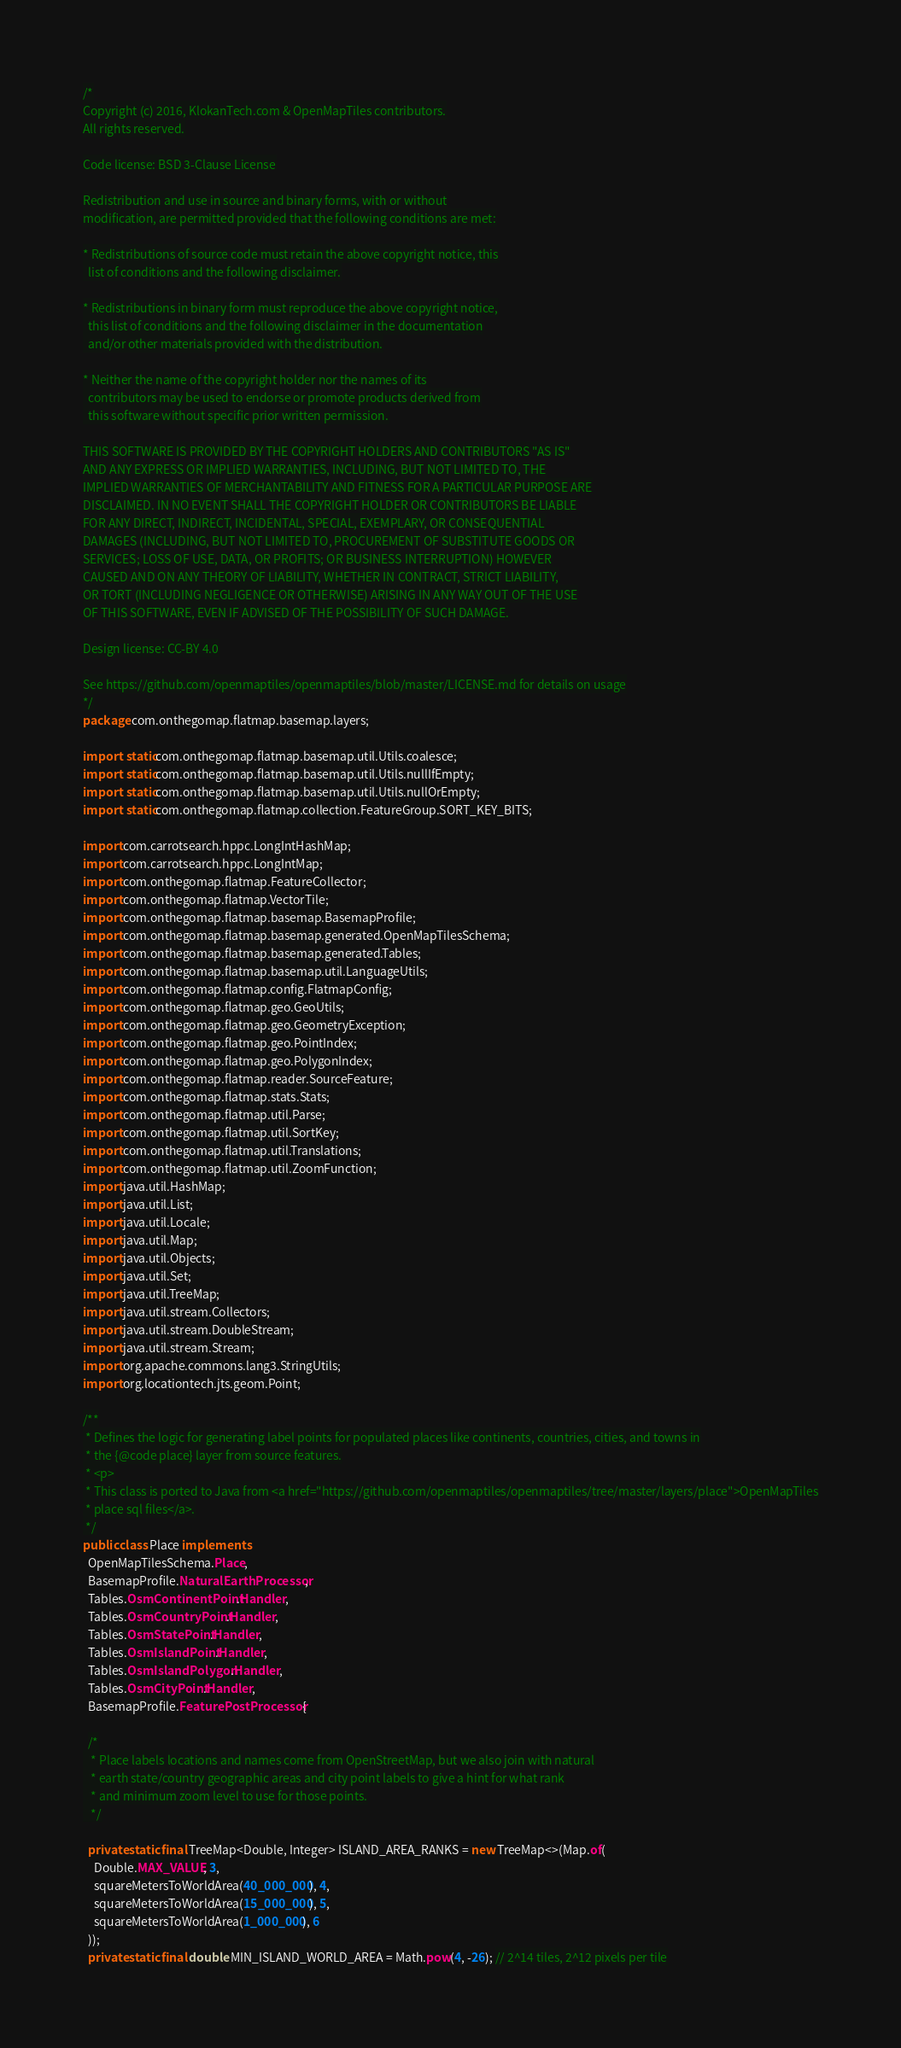Convert code to text. <code><loc_0><loc_0><loc_500><loc_500><_Java_>/*
Copyright (c) 2016, KlokanTech.com & OpenMapTiles contributors.
All rights reserved.

Code license: BSD 3-Clause License

Redistribution and use in source and binary forms, with or without
modification, are permitted provided that the following conditions are met:

* Redistributions of source code must retain the above copyright notice, this
  list of conditions and the following disclaimer.

* Redistributions in binary form must reproduce the above copyright notice,
  this list of conditions and the following disclaimer in the documentation
  and/or other materials provided with the distribution.

* Neither the name of the copyright holder nor the names of its
  contributors may be used to endorse or promote products derived from
  this software without specific prior written permission.

THIS SOFTWARE IS PROVIDED BY THE COPYRIGHT HOLDERS AND CONTRIBUTORS "AS IS"
AND ANY EXPRESS OR IMPLIED WARRANTIES, INCLUDING, BUT NOT LIMITED TO, THE
IMPLIED WARRANTIES OF MERCHANTABILITY AND FITNESS FOR A PARTICULAR PURPOSE ARE
DISCLAIMED. IN NO EVENT SHALL THE COPYRIGHT HOLDER OR CONTRIBUTORS BE LIABLE
FOR ANY DIRECT, INDIRECT, INCIDENTAL, SPECIAL, EXEMPLARY, OR CONSEQUENTIAL
DAMAGES (INCLUDING, BUT NOT LIMITED TO, PROCUREMENT OF SUBSTITUTE GOODS OR
SERVICES; LOSS OF USE, DATA, OR PROFITS; OR BUSINESS INTERRUPTION) HOWEVER
CAUSED AND ON ANY THEORY OF LIABILITY, WHETHER IN CONTRACT, STRICT LIABILITY,
OR TORT (INCLUDING NEGLIGENCE OR OTHERWISE) ARISING IN ANY WAY OUT OF THE USE
OF THIS SOFTWARE, EVEN IF ADVISED OF THE POSSIBILITY OF SUCH DAMAGE.

Design license: CC-BY 4.0

See https://github.com/openmaptiles/openmaptiles/blob/master/LICENSE.md for details on usage
*/
package com.onthegomap.flatmap.basemap.layers;

import static com.onthegomap.flatmap.basemap.util.Utils.coalesce;
import static com.onthegomap.flatmap.basemap.util.Utils.nullIfEmpty;
import static com.onthegomap.flatmap.basemap.util.Utils.nullOrEmpty;
import static com.onthegomap.flatmap.collection.FeatureGroup.SORT_KEY_BITS;

import com.carrotsearch.hppc.LongIntHashMap;
import com.carrotsearch.hppc.LongIntMap;
import com.onthegomap.flatmap.FeatureCollector;
import com.onthegomap.flatmap.VectorTile;
import com.onthegomap.flatmap.basemap.BasemapProfile;
import com.onthegomap.flatmap.basemap.generated.OpenMapTilesSchema;
import com.onthegomap.flatmap.basemap.generated.Tables;
import com.onthegomap.flatmap.basemap.util.LanguageUtils;
import com.onthegomap.flatmap.config.FlatmapConfig;
import com.onthegomap.flatmap.geo.GeoUtils;
import com.onthegomap.flatmap.geo.GeometryException;
import com.onthegomap.flatmap.geo.PointIndex;
import com.onthegomap.flatmap.geo.PolygonIndex;
import com.onthegomap.flatmap.reader.SourceFeature;
import com.onthegomap.flatmap.stats.Stats;
import com.onthegomap.flatmap.util.Parse;
import com.onthegomap.flatmap.util.SortKey;
import com.onthegomap.flatmap.util.Translations;
import com.onthegomap.flatmap.util.ZoomFunction;
import java.util.HashMap;
import java.util.List;
import java.util.Locale;
import java.util.Map;
import java.util.Objects;
import java.util.Set;
import java.util.TreeMap;
import java.util.stream.Collectors;
import java.util.stream.DoubleStream;
import java.util.stream.Stream;
import org.apache.commons.lang3.StringUtils;
import org.locationtech.jts.geom.Point;

/**
 * Defines the logic for generating label points for populated places like continents, countries, cities, and towns in
 * the {@code place} layer from source features.
 * <p>
 * This class is ported to Java from <a href="https://github.com/openmaptiles/openmaptiles/tree/master/layers/place">OpenMapTiles
 * place sql files</a>.
 */
public class Place implements
  OpenMapTilesSchema.Place,
  BasemapProfile.NaturalEarthProcessor,
  Tables.OsmContinentPoint.Handler,
  Tables.OsmCountryPoint.Handler,
  Tables.OsmStatePoint.Handler,
  Tables.OsmIslandPoint.Handler,
  Tables.OsmIslandPolygon.Handler,
  Tables.OsmCityPoint.Handler,
  BasemapProfile.FeaturePostProcessor {

  /*
   * Place labels locations and names come from OpenStreetMap, but we also join with natural
   * earth state/country geographic areas and city point labels to give a hint for what rank
   * and minimum zoom level to use for those points.
   */

  private static final TreeMap<Double, Integer> ISLAND_AREA_RANKS = new TreeMap<>(Map.of(
    Double.MAX_VALUE, 3,
    squareMetersToWorldArea(40_000_000), 4,
    squareMetersToWorldArea(15_000_000), 5,
    squareMetersToWorldArea(1_000_000), 6
  ));
  private static final double MIN_ISLAND_WORLD_AREA = Math.pow(4, -26); // 2^14 tiles, 2^12 pixels per tile</code> 